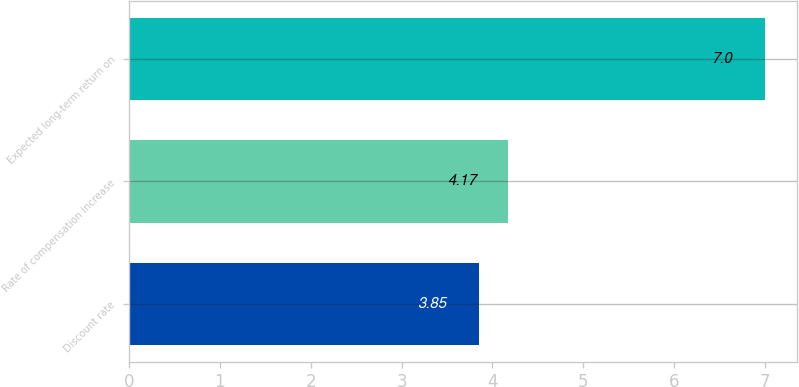Convert chart to OTSL. <chart><loc_0><loc_0><loc_500><loc_500><bar_chart><fcel>Discount rate<fcel>Rate of compensation increase<fcel>Expected long-term return on<nl><fcel>3.85<fcel>4.17<fcel>7<nl></chart> 